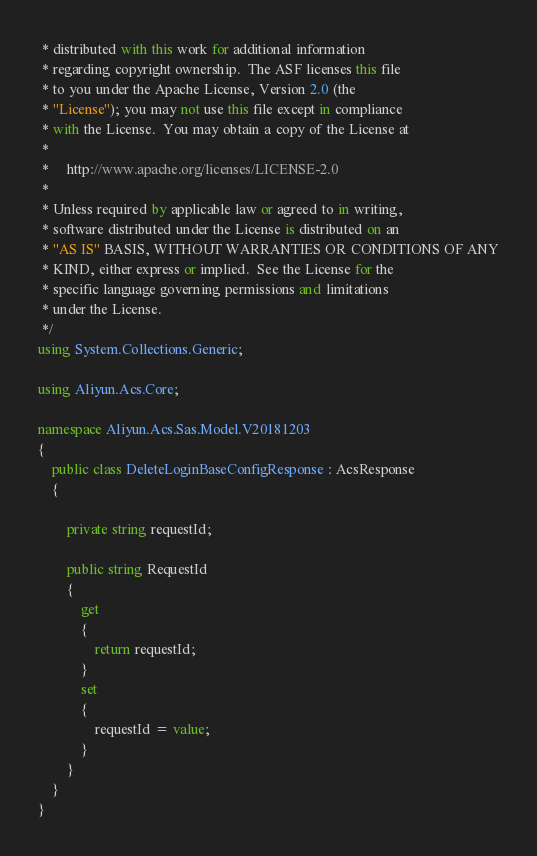<code> <loc_0><loc_0><loc_500><loc_500><_C#_> * distributed with this work for additional information
 * regarding copyright ownership.  The ASF licenses this file
 * to you under the Apache License, Version 2.0 (the
 * "License"); you may not use this file except in compliance
 * with the License.  You may obtain a copy of the License at
 *
 *     http://www.apache.org/licenses/LICENSE-2.0
 *
 * Unless required by applicable law or agreed to in writing,
 * software distributed under the License is distributed on an
 * "AS IS" BASIS, WITHOUT WARRANTIES OR CONDITIONS OF ANY
 * KIND, either express or implied.  See the License for the
 * specific language governing permissions and limitations
 * under the License.
 */
using System.Collections.Generic;

using Aliyun.Acs.Core;

namespace Aliyun.Acs.Sas.Model.V20181203
{
	public class DeleteLoginBaseConfigResponse : AcsResponse
	{

		private string requestId;

		public string RequestId
		{
			get
			{
				return requestId;
			}
			set	
			{
				requestId = value;
			}
		}
	}
}
</code> 